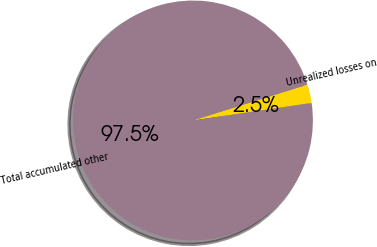<chart> <loc_0><loc_0><loc_500><loc_500><pie_chart><fcel>Unrealized losses on<fcel>Total accumulated other<nl><fcel>2.5%<fcel>97.5%<nl></chart> 